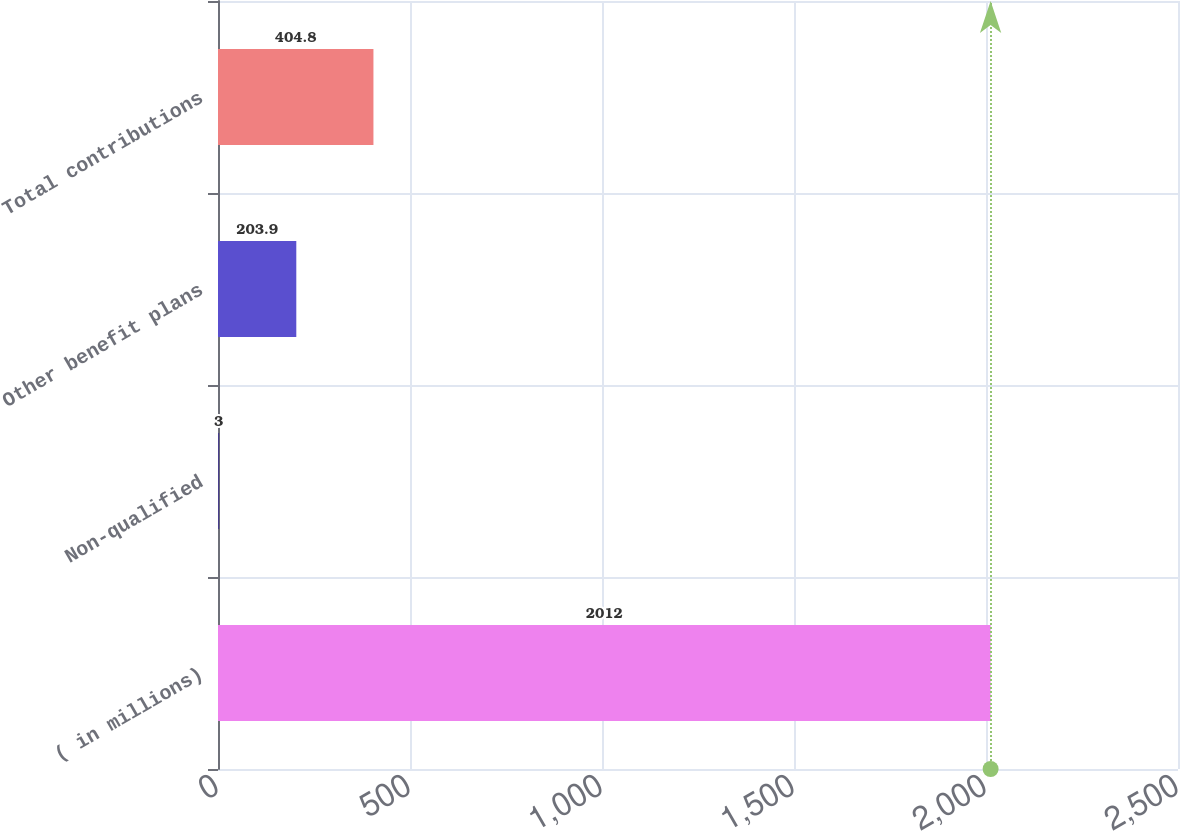Convert chart to OTSL. <chart><loc_0><loc_0><loc_500><loc_500><bar_chart><fcel>( in millions)<fcel>Non-qualified<fcel>Other benefit plans<fcel>Total contributions<nl><fcel>2012<fcel>3<fcel>203.9<fcel>404.8<nl></chart> 